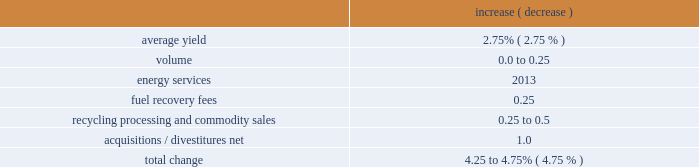Incremental contract start-up costs 2014large municipal contract .
During 2018 and 2017 , we incurred costs of $ 5.7 million and $ 8.2 million , respectively , related to the implementation of a large municipal contract .
These costs did not meet the capitalization criteria prescribed by the new revenue recognition standard .
Adoption of the tax act .
The tax act was enacted on december 22 , 2017 .
Among other things , the tax act reduced the u.s .
Federal corporate tax rate from 35% ( 35 % ) to 21% ( 21 % ) .
For the year ended december 31 , 2017 , we recorded provisional amounts based on our estimates of the tax act 2019s effect to our deferred taxes , uncertain tax positions , and one-time transition tax .
These adjustments reduced our tax provision by $ 463.9 million .
During 2018 , we adjusted the provisional amounts recorded as of december 31 , 2017 for the one-time transition tax , deferred taxes and uncertain tax positions .
These adjustments increased our tax provision by $ 0.3 million .
Bridgeton insurance recovery , net .
During 2018 , we collected an insurance recovery of $ 40.0 million related to our closed bridgeton landfill in missouri , which we recognized as a reduction of remediation expenses in our cost of operations .
In addition , we incurred $ 12.0 million of incremental costs attributable to the bridgeton insurance recovery .
Recent developments 2019 financial guidance in 2019 , we will continue to focus on managing the controllable aspects of our business by enhancing the quality of our revenue , investing in profitable growth opportunities and reducing costs .
Our team remains focused on executing our strategy to deliver consistent earnings and free cash flow growth , and improve return on invested capital .
We are committed to an efficient capital structure , maintaining our investment grade credit ratings and increasing cash returned to our shareholders .
Our guidance is based on current economic conditions and does not assume any significant changes in the overall economy in 2019 .
Specific guidance follows : revenue we expect 2019 revenue to increase by approximately 4.25 to 4.75% ( 4.75 % ) comprised of the following : increase ( decrease ) .
Changes in price are restricted on approximately 50% ( 50 % ) of our annual service revenue .
The majority of these restricted pricing arrangements are tied to fluctuations in a specific index ( primarily a consumer price index ) as defined in the contract .
The consumer price index varies from a single historical stated period of time or an average of trailing historical rates over a stated period of time .
In addition , the initial effect of pricing resets typically lags 6 to 12 months from the end of the index measurement period to the date the revised pricing goes into effect .
As a result , current changes in a specific index may not manifest themselves in our reported pricing for several quarters into the future. .
What is the ratio of the insurance recovery to the incremental cost related to our closed bridgeton landfill? 
Rationale: there was $ 3.33 of insurance recovery related to the insurance recovery for every dollar if incremental costs related to the of closed bridgeton landfill
Computations: (40.0 / 12.0)
Answer: 3.33333. 